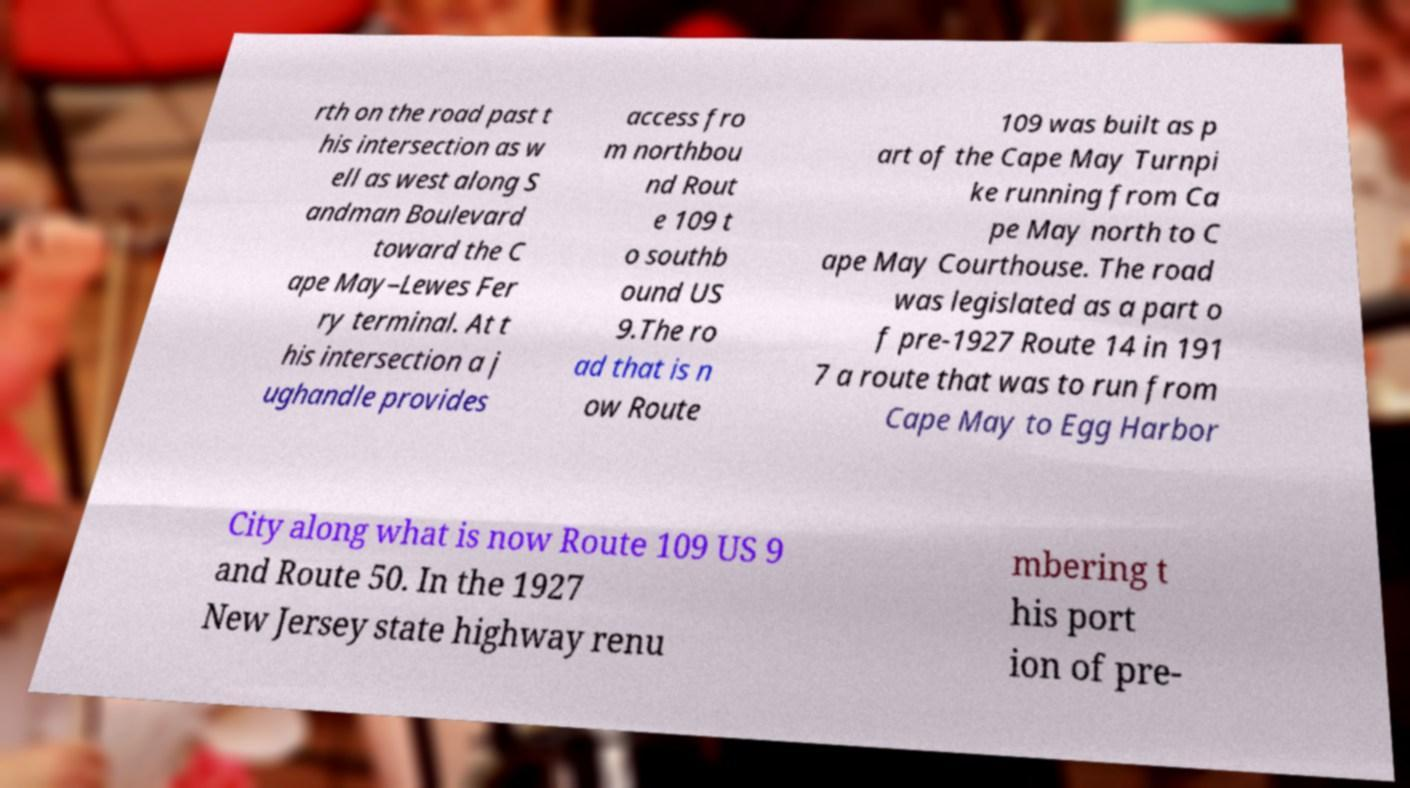I need the written content from this picture converted into text. Can you do that? rth on the road past t his intersection as w ell as west along S andman Boulevard toward the C ape May–Lewes Fer ry terminal. At t his intersection a j ughandle provides access fro m northbou nd Rout e 109 t o southb ound US 9.The ro ad that is n ow Route 109 was built as p art of the Cape May Turnpi ke running from Ca pe May north to C ape May Courthouse. The road was legislated as a part o f pre-1927 Route 14 in 191 7 a route that was to run from Cape May to Egg Harbor City along what is now Route 109 US 9 and Route 50. In the 1927 New Jersey state highway renu mbering t his port ion of pre- 